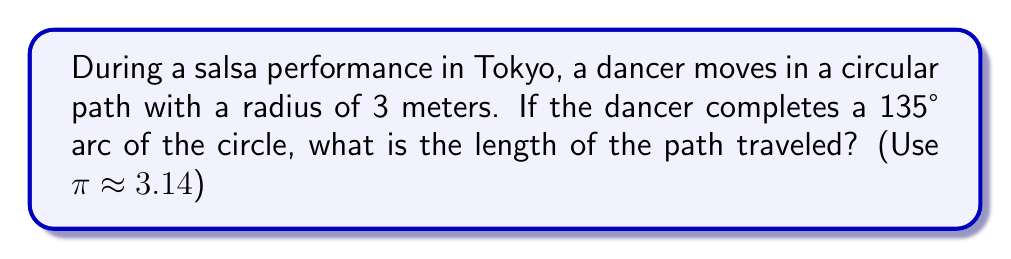What is the answer to this math problem? Let's approach this step-by-step:

1) The formula for arc length is:
   $$s = r\theta$$
   where $s$ is the arc length, $r$ is the radius, and $\theta$ is the central angle in radians.

2) We're given the radius $r = 3$ meters and the angle in degrees (135°).

3) We need to convert 135° to radians:
   $$\theta = 135° \cdot \frac{\pi}{180°} = \frac{3\pi}{4} \text{ radians}$$

4) Now we can substitute these values into our formula:
   $$s = r\theta = 3 \cdot \frac{3\pi}{4}$$

5) Simplify:
   $$s = \frac{9\pi}{4} \text{ meters}$$

6) Using $\pi \approx 3.14$, we can calculate the approximate value:
   $$s \approx \frac{9 \cdot 3.14}{4} = 7.065 \text{ meters}$$

Therefore, the dancer travels approximately 7.07 meters along the circular path.
Answer: $7.07 \text{ m}$ 